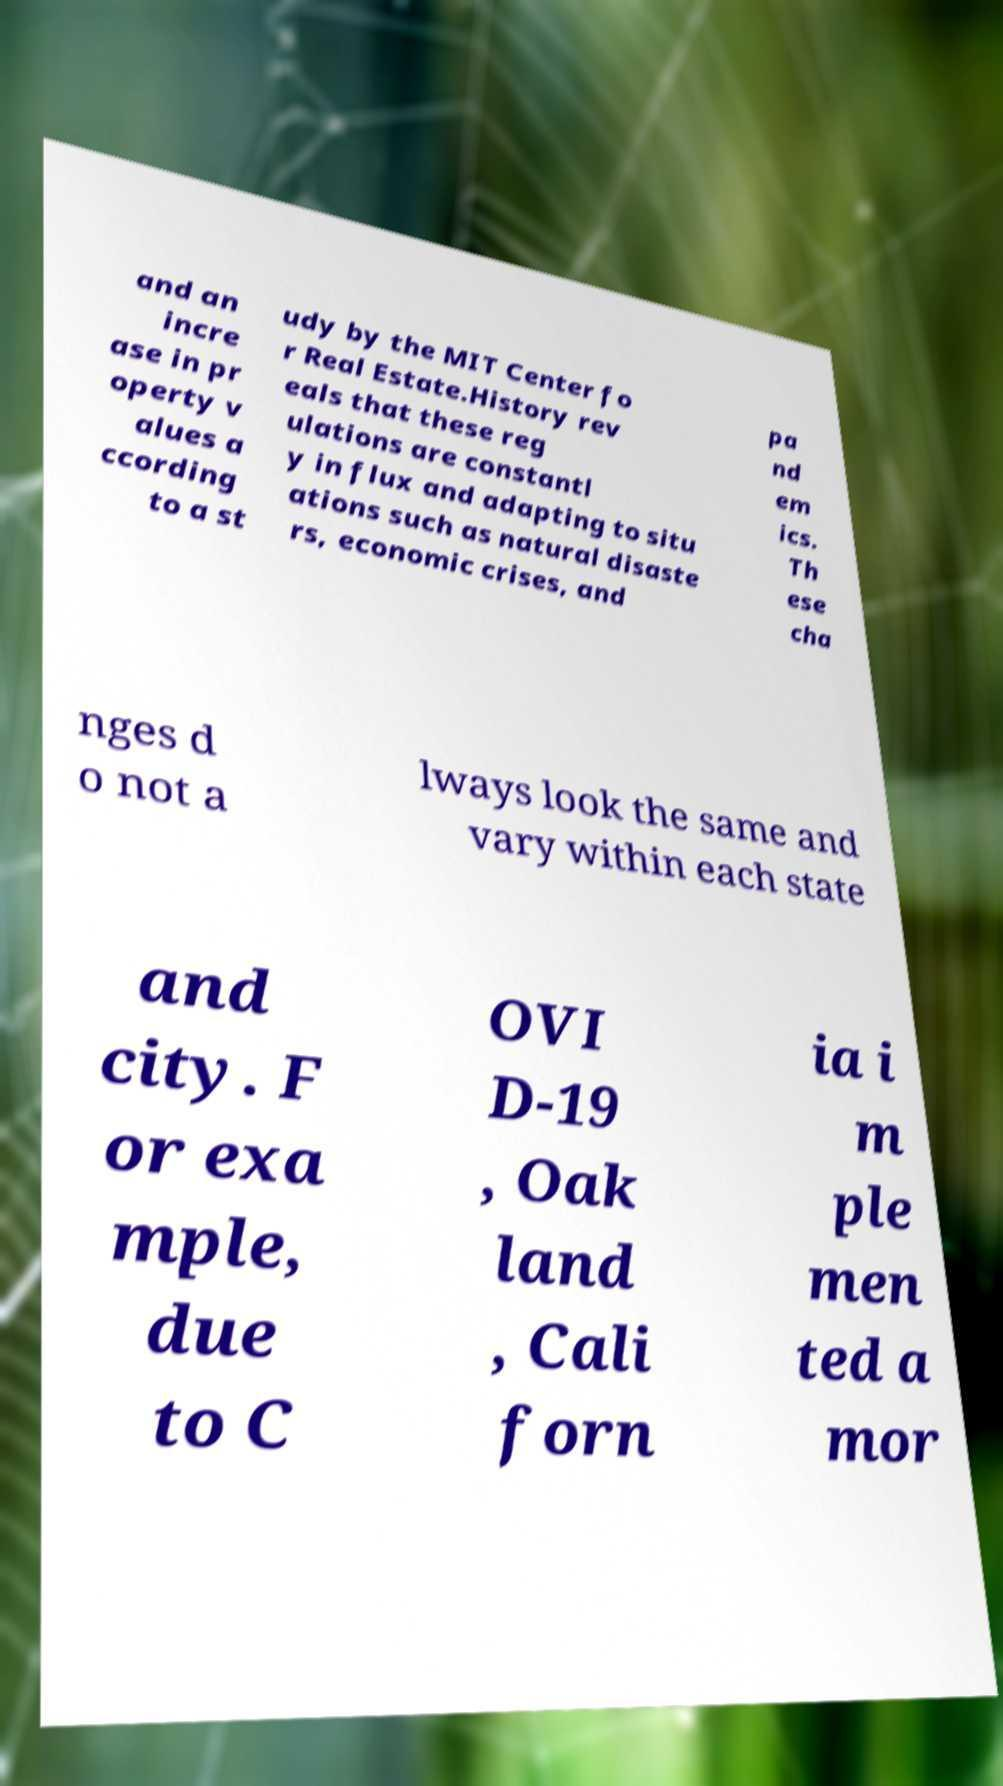There's text embedded in this image that I need extracted. Can you transcribe it verbatim? and an incre ase in pr operty v alues a ccording to a st udy by the MIT Center fo r Real Estate.History rev eals that these reg ulations are constantl y in flux and adapting to situ ations such as natural disaste rs, economic crises, and pa nd em ics. Th ese cha nges d o not a lways look the same and vary within each state and city. F or exa mple, due to C OVI D-19 , Oak land , Cali forn ia i m ple men ted a mor 